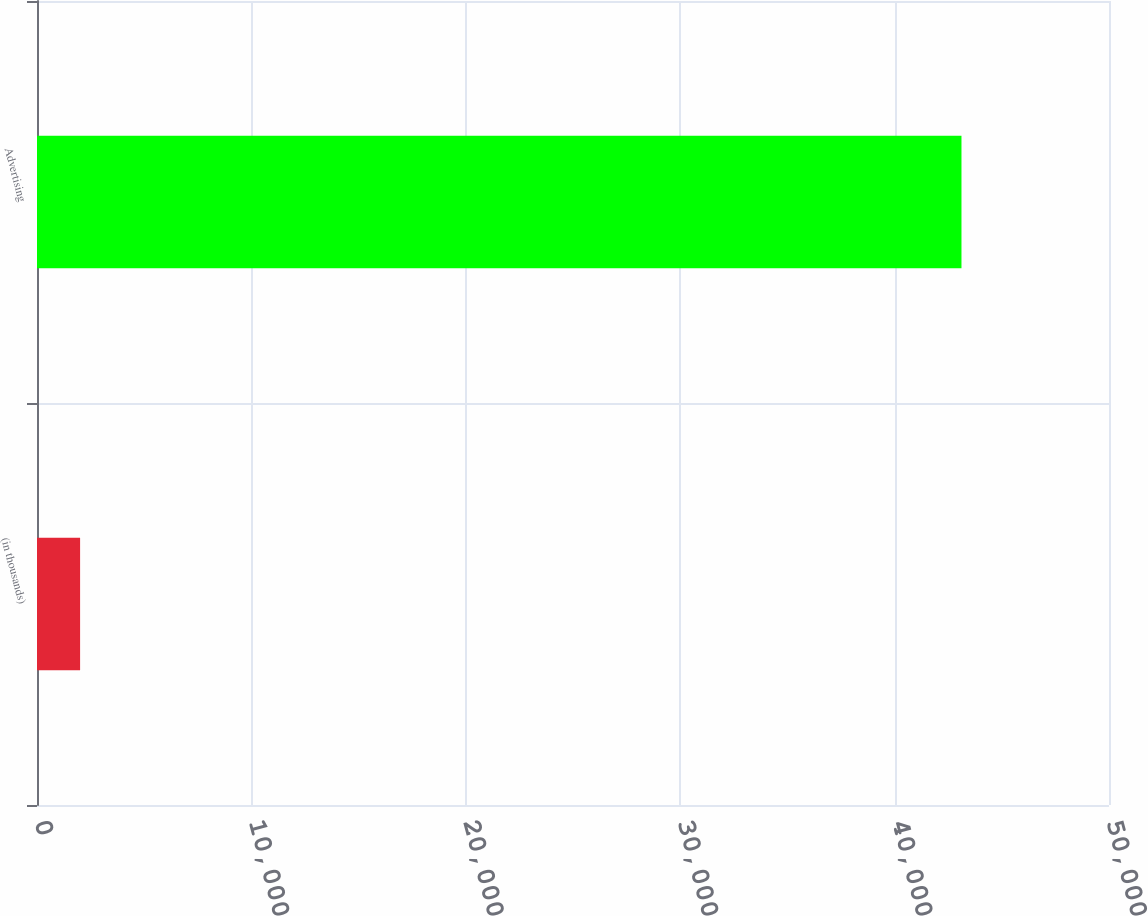Convert chart. <chart><loc_0><loc_0><loc_500><loc_500><bar_chart><fcel>(in thousands)<fcel>Advertising<nl><fcel>2010<fcel>43119<nl></chart> 